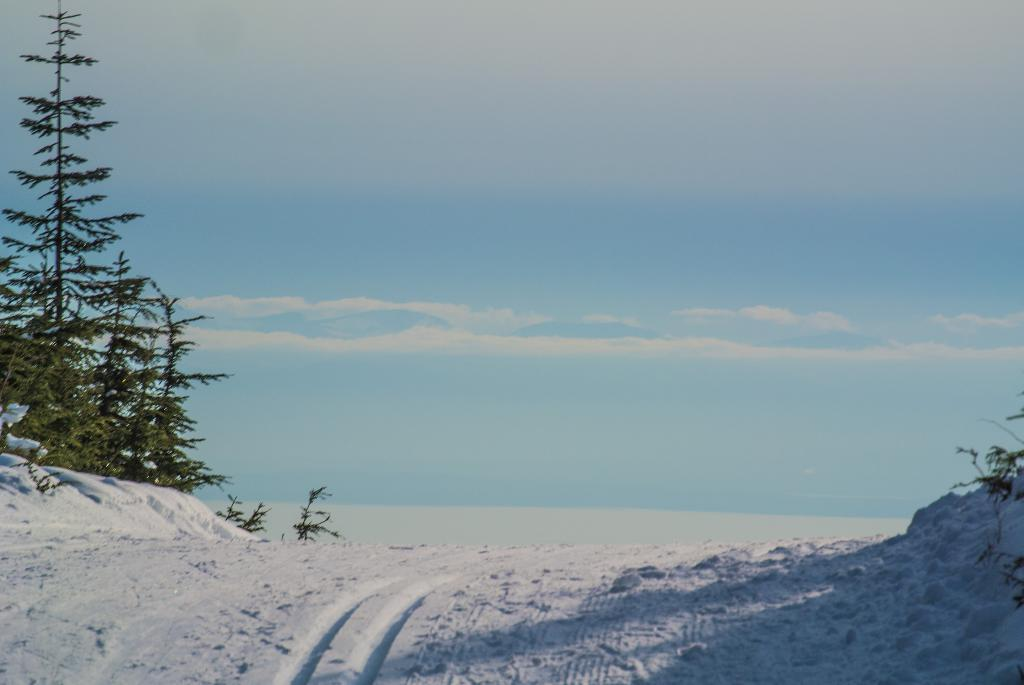What type of weather condition is depicted in the image? There is snow in the image, indicating a cold or wintry weather condition. What natural elements can be seen in the image? There are trees and snow in the image. What is visible in the background of the image? The sky is visible in the image, and clouds are present in the sky. What type of milk is being produced by the hen in the image? There is no hen or milk present in the image; it features snow, trees, and a sky with clouds. 